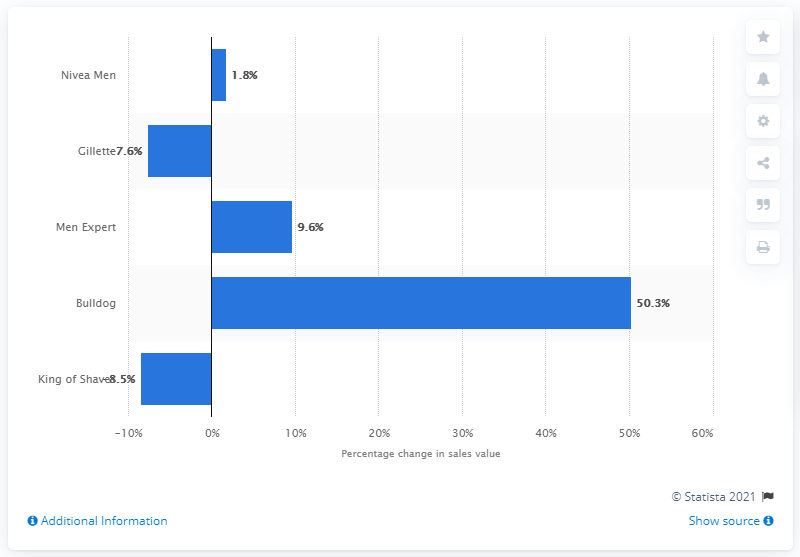Draw attention to some important aspects in this diagram. The skincare brand with the highest sales growth among men is Bulldog. 